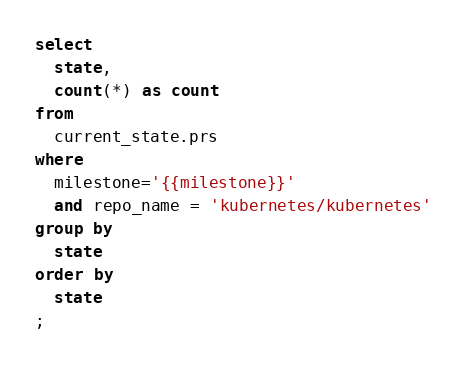<code> <loc_0><loc_0><loc_500><loc_500><_SQL_>select
  state,
  count(*) as count
from
  current_state.prs
where
  milestone='{{milestone}}'
  and repo_name = 'kubernetes/kubernetes'
group by
  state
order by
  state
;
</code> 